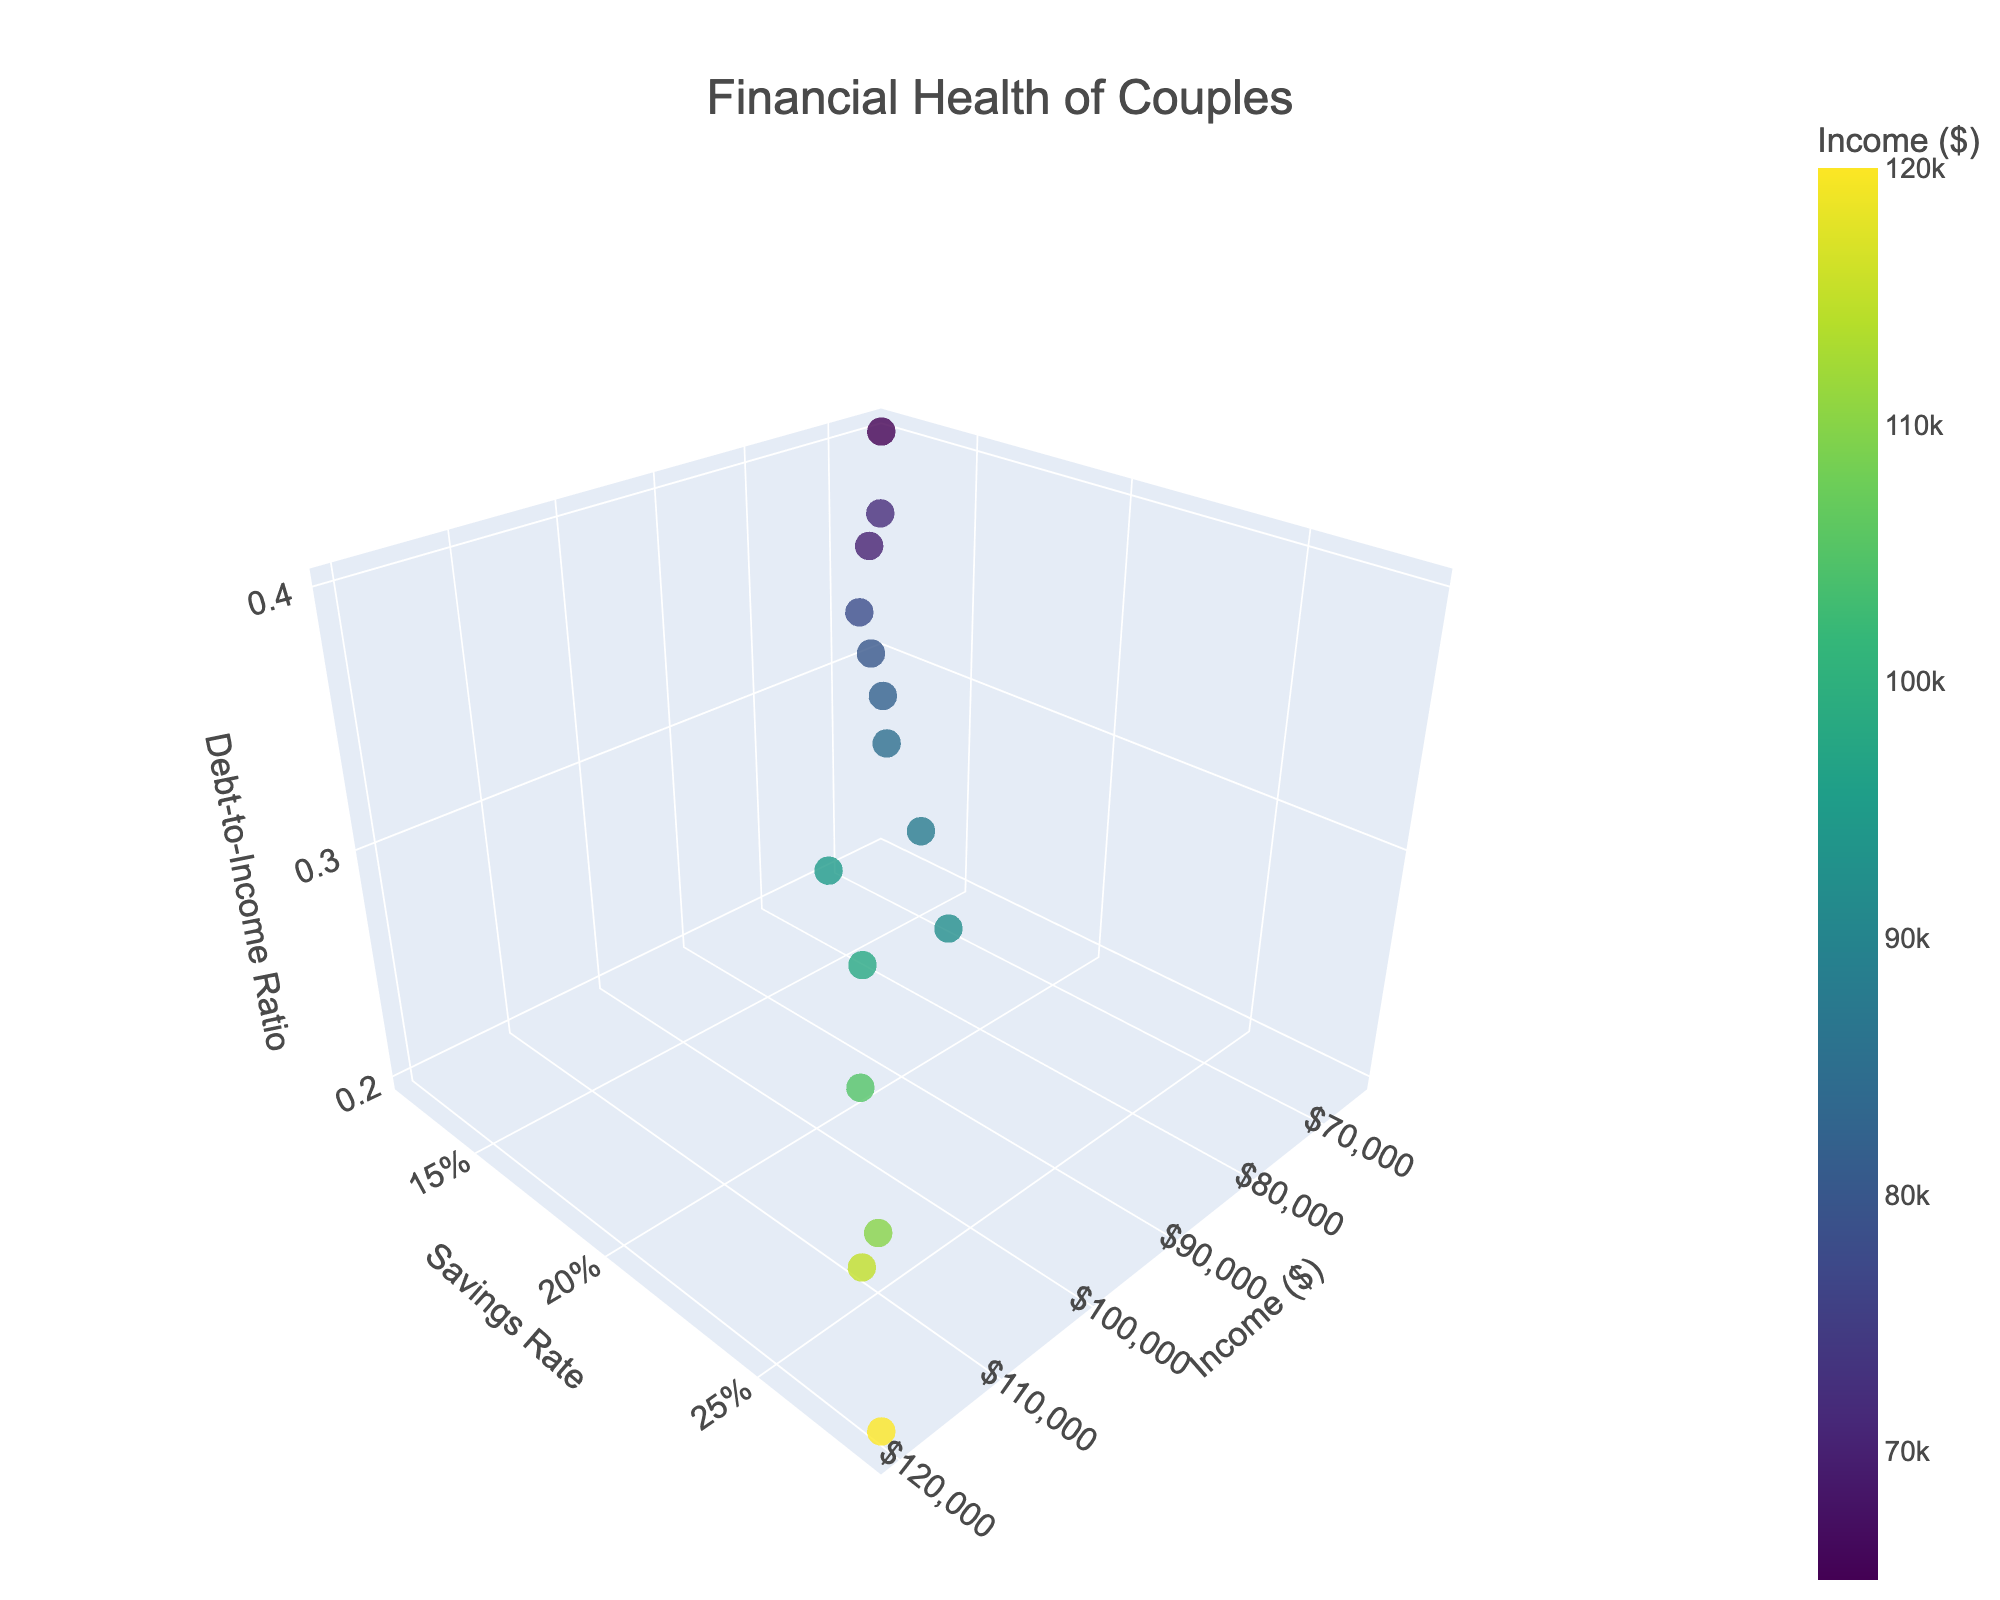What's the title of the figure? The title is displayed at the top center of the figure. It reads "Financial Health of Couples".
Answer: Financial Health of Couples What axis represents the Savings Rate? The axis labels provide this information. The y-axis is labeled "Savings Rate".
Answer: y-axis How many data points are plotted in the figure? The figure contains a total of 15 markers, corresponding to 15 data points.
Answer: 15 Which couple has the highest Income? The Income value is highest for the data point positioned the farthest on the x-axis. This data point is at $120,000.
Answer: The couple with $120,000 Income What is the Debt-to-Income Ratio for a couple with an Income of $105,000? To find this, look for the data point with an x-axis value of $105,000, then check its position on the z-axis. The Debt-to-Income Ratio for this couple is 0.25.
Answer: 0.25 Which couple has the lowest Savings Rate? The data point with the lowest value on the y-axis represents the couple with the lowest Savings Rate. This is 0.12.
Answer: The couple with a 0.12 Savings Rate Among couples with an Income higher than $90,000, which one has the highest Debt-to-Income Ratio? First, identify couples with an Income over $90,000. Among these, the couple located highest on the z-axis (Debt-to-Income Ratio) has an Income of $95,000 and a Debt-to-Income Ratio of 0.29.
Answer: The couple with $95,000 Income Is there a couple with equal Savings Rate and Debt-to-Income Ratio? To find this, check if any data point has identical y and z-axis values. There is no such data point where the Savings Rate equals the Debt-to-Income Ratio.
Answer: No What is the average Savings Rate of couples with an Income between $70,000 and $90,000? Couples in this range are those with $85,000, $78,000, $65,000, $88,000, $72,000, $82,000, $70,000, and $80,000. Their Savings Rates are 0.18, 0.15, 0.12, 0.20, 0.14, 0.17, 0.13, and 0.16. The average is (0.18 + 0.15 + 0.12 + 0.20 + 0.14 + 0.17 + 0.13 + 0.16)/8 = 0.15625.
Answer: 0.15625 What is the range of Debt-to-Income Ratios among couples with the top five highest Incomes? The top five highest Incomes are $120,000, $115,000, $110,000, $105,000, and $98,000 with Debt-to-Income Ratios of 0.20, 0.23, 0.22, 0.25, and 0.27 respectively. The range is 0.27 - 0.20.
Answer: 0.07 